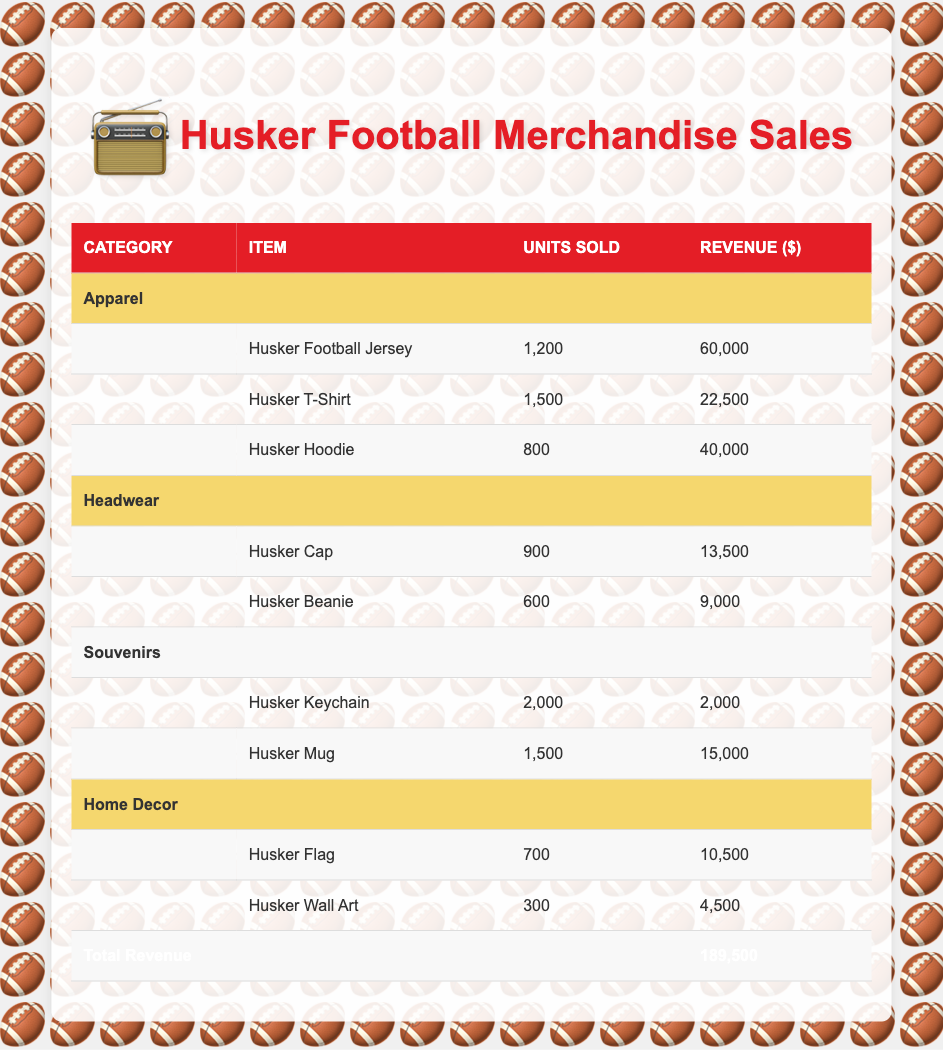What is the total revenue from merchandise sales? The total revenue is clearly stated at the bottom of the table, which summarizes all the revenue contributions from different merchandise categories. According to the table, the total revenue is 189,500.
Answer: 189,500 How many Husker T-Shirts were sold? The table specifies the sales data for each item under the Apparel category. The row for the Husker T-Shirt shows that 1,500 units were sold.
Answer: 1,500 Is the revenue from Husker Hoodies greater than the combined revenue of Husker Caps and Husker Beanies? To determine this, first, we check the revenue for Husker Hoodies, which is 40,000. Then, we add the revenues for Husker Caps (13,500) and Husker Beanies (9,000). The combined revenue for these two items is 22,500. Since 40,000 is greater than 22,500, the statement is true.
Answer: Yes What percentage of the total revenue comes from apparel merchandise? The total revenue is 189,500, and the total revenue from apparel is the sum of all revenues in that category: 60,000 (Jersey) + 22,500 (T-Shirt) + 40,000 (Hoodie) = 122,500. To find the percentage, we use the formula: (122,500 / 189,500) * 100, which equals approximately 64.6%.
Answer: 64.6% Which item sold the highest number of units? The table lists the units sold for each item across all categories. The Husker Keychain has the highest units sold at 2,000, more than any other item listed.
Answer: Husker Keychain What is the total revenue generated from Headwear merchandise? To find this total, we need to add the revenue for both items in the Headwear category: Husker Cap, which is 13,500, and Husker Beanie, which is 9,000. Adding these gives us 22,500 for the Headwear category.
Answer: 22,500 Did Husker Wall Art generate more revenue than Husker Mugs? The revenue for Husker Wall Art is listed as 4,500 while the revenue for Husker Mugs is 15,000. Comparing these, 4,500 is less than 15,000, so the statement is false.
Answer: No By how much does the revenue from souvenirs exceed the revenue from Home Decor? First, we find the total revenue from souvenirs, which is 2,000 (Keychain) + 15,000 (Mug) = 17,000. For Home Decor, the revenue is 10,500 (Flag) + 4,500 (Wall Art) = 15,000. Now, we subtract the Home Decor revenue from the souvenirs revenue: 17,000 - 15,000 = 2,000.
Answer: 2,000 